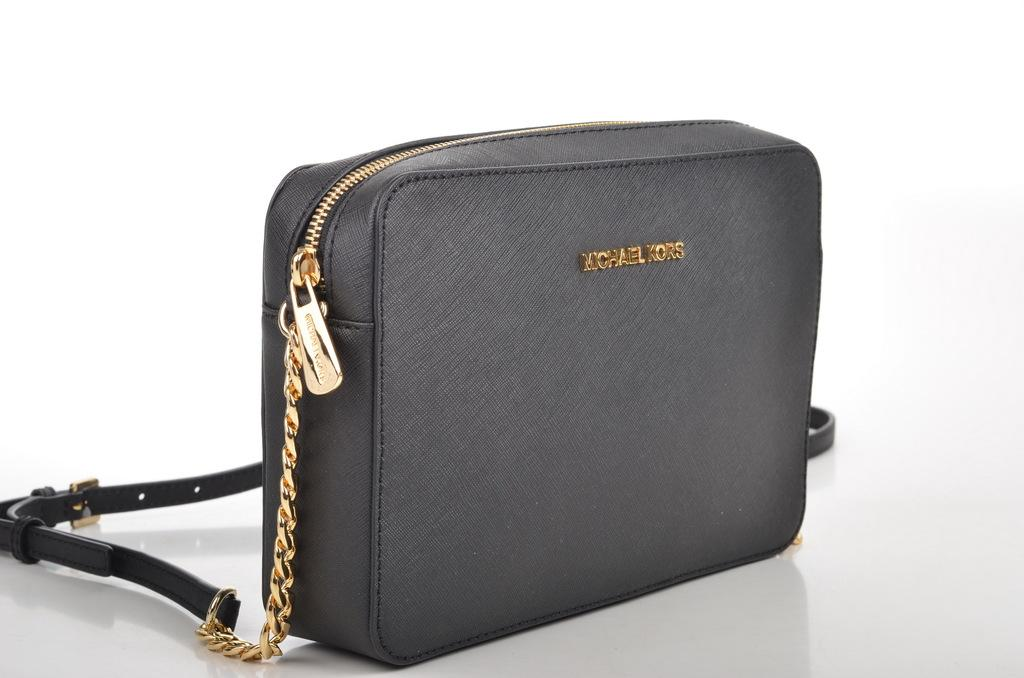What object can be seen in the image? There is a bag in the image. What type of frame is surrounding the bag in the image? There is no frame surrounding the bag in the image. Is there a coach present in the image? There is no coach present in the image. 